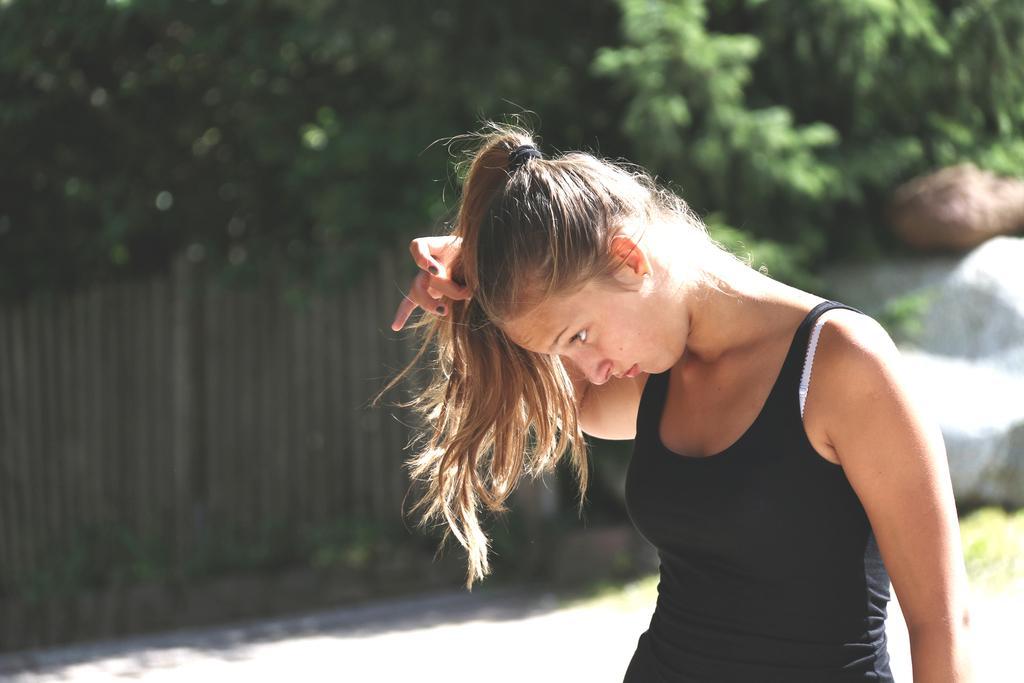Describe this image in one or two sentences. In this picture I can see a woman is standing and wearing a black color dress. In the background I can see a wooden fence and trees. 